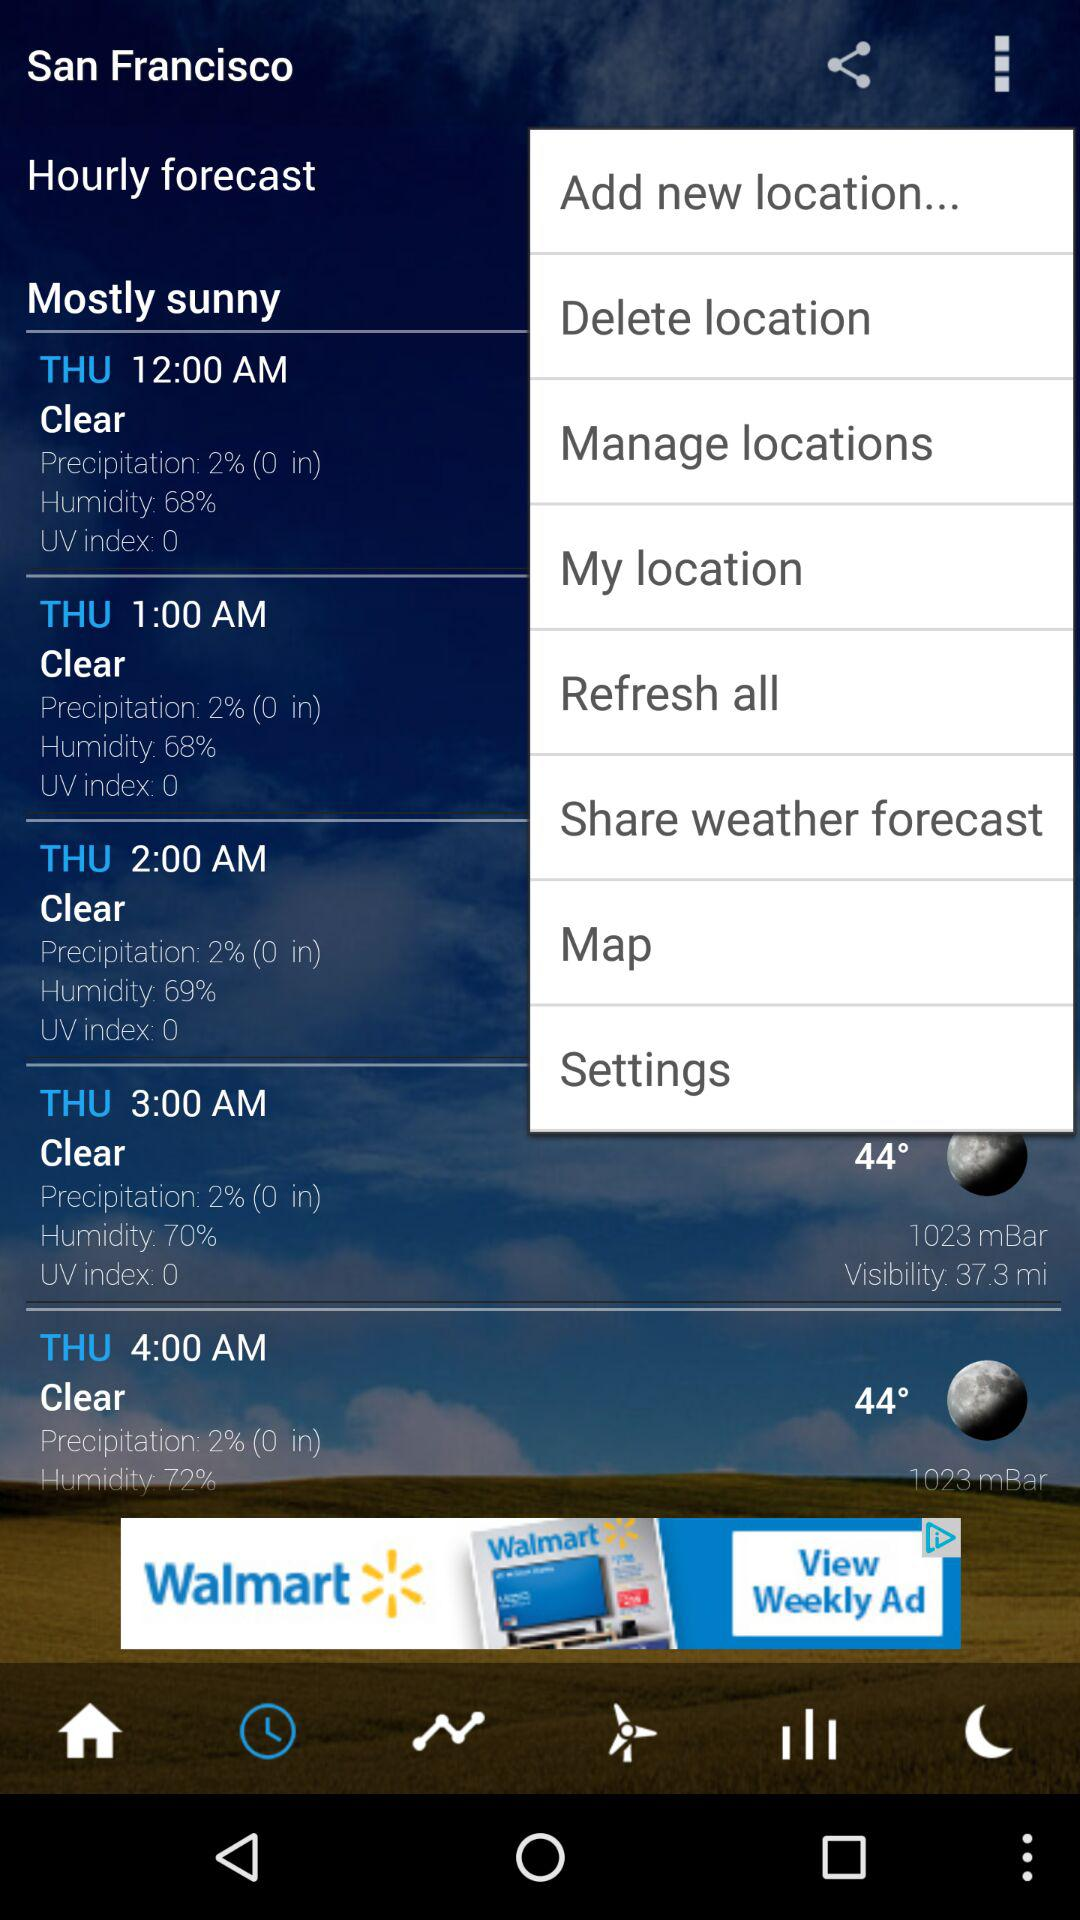What is the location? The location is San Francisco. 